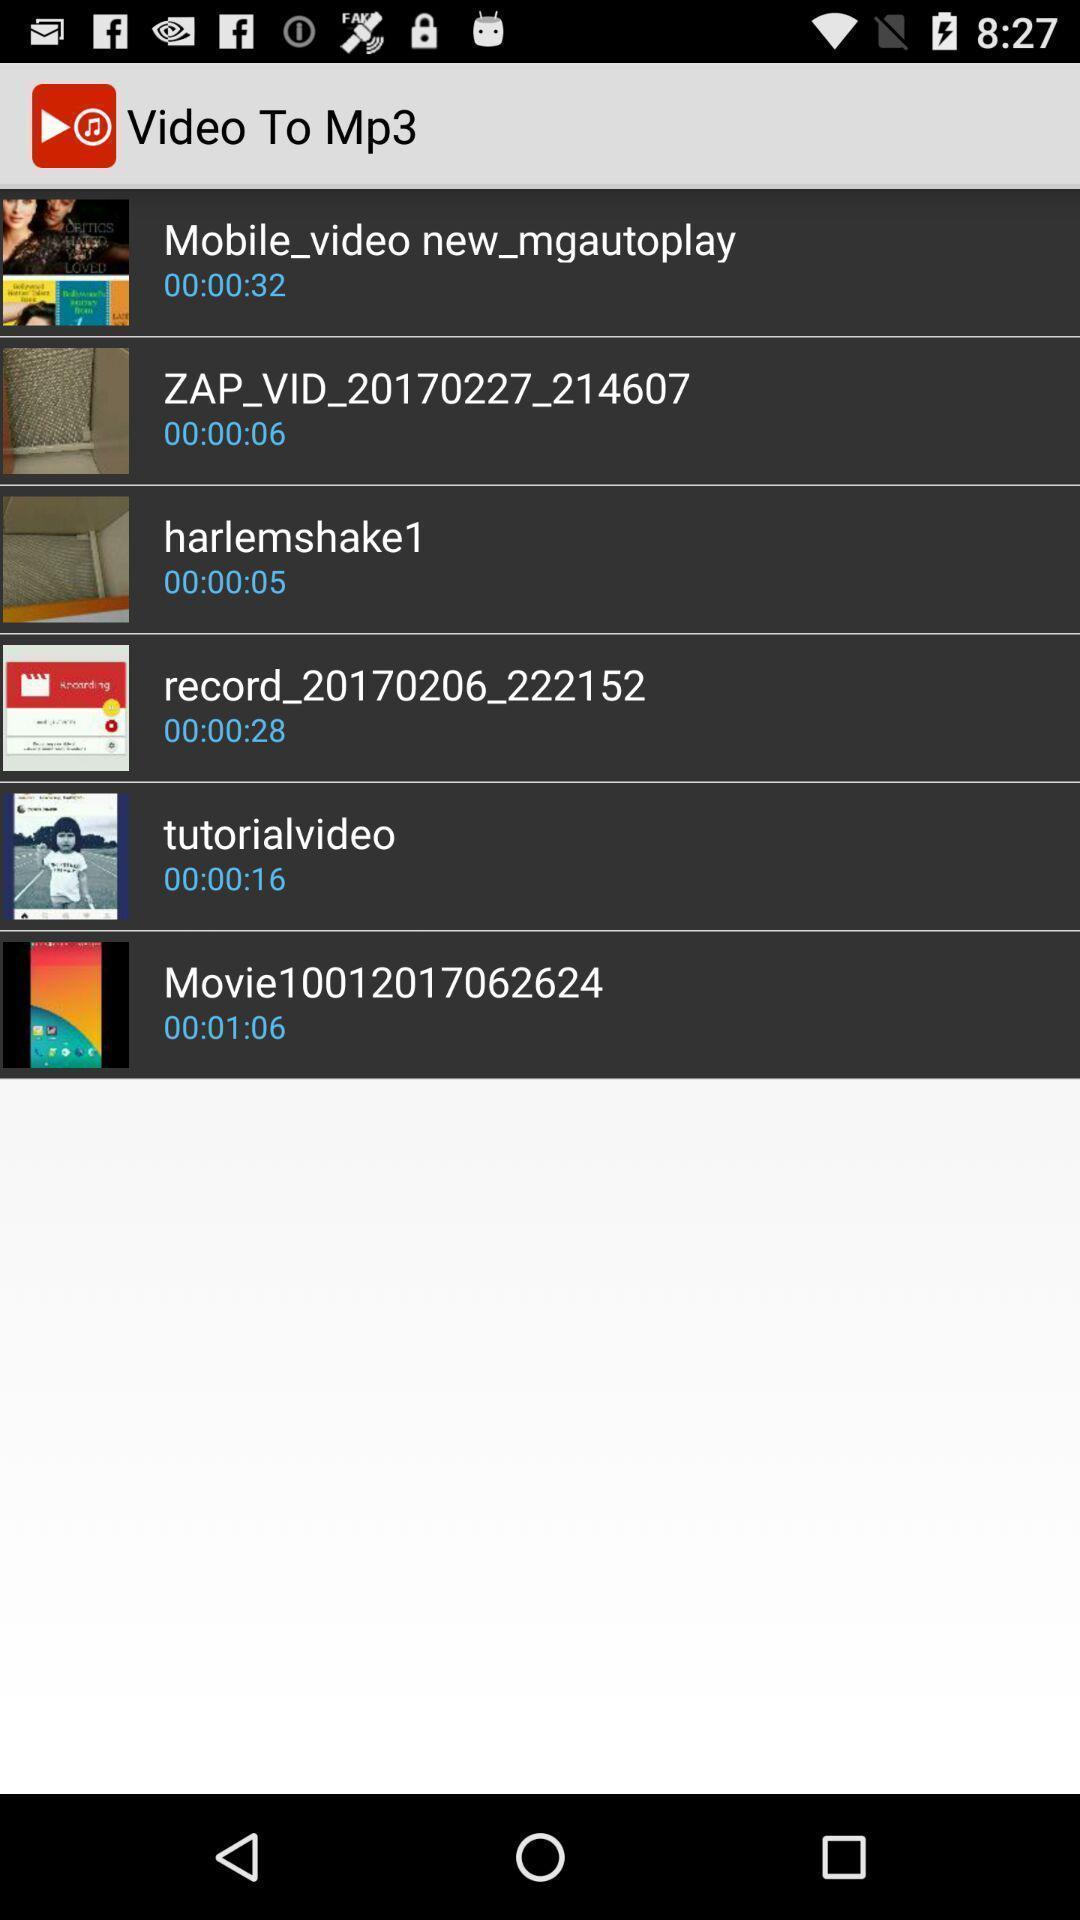Describe the key features of this screenshot. Page showing video recording app. 